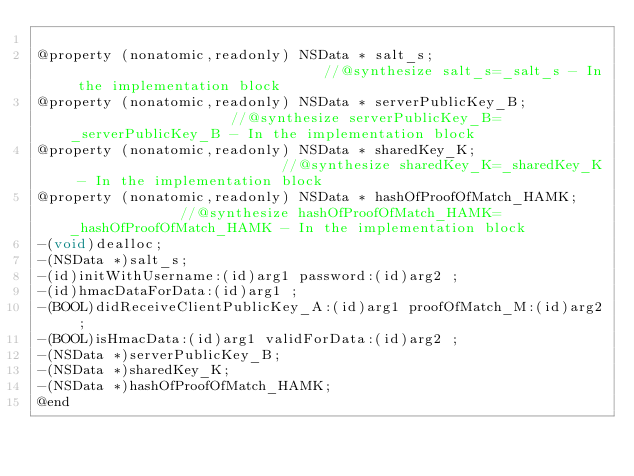Convert code to text. <code><loc_0><loc_0><loc_500><loc_500><_C_>
@property (nonatomic,readonly) NSData * salt_s;                               //@synthesize salt_s=_salt_s - In the implementation block
@property (nonatomic,readonly) NSData * serverPublicKey_B;                    //@synthesize serverPublicKey_B=_serverPublicKey_B - In the implementation block
@property (nonatomic,readonly) NSData * sharedKey_K;                          //@synthesize sharedKey_K=_sharedKey_K - In the implementation block
@property (nonatomic,readonly) NSData * hashOfProofOfMatch_HAMK;              //@synthesize hashOfProofOfMatch_HAMK=_hashOfProofOfMatch_HAMK - In the implementation block
-(void)dealloc;
-(NSData *)salt_s;
-(id)initWithUsername:(id)arg1 password:(id)arg2 ;
-(id)hmacDataForData:(id)arg1 ;
-(BOOL)didReceiveClientPublicKey_A:(id)arg1 proofOfMatch_M:(id)arg2 ;
-(BOOL)isHmacData:(id)arg1 validForData:(id)arg2 ;
-(NSData *)serverPublicKey_B;
-(NSData *)sharedKey_K;
-(NSData *)hashOfProofOfMatch_HAMK;
@end

</code> 